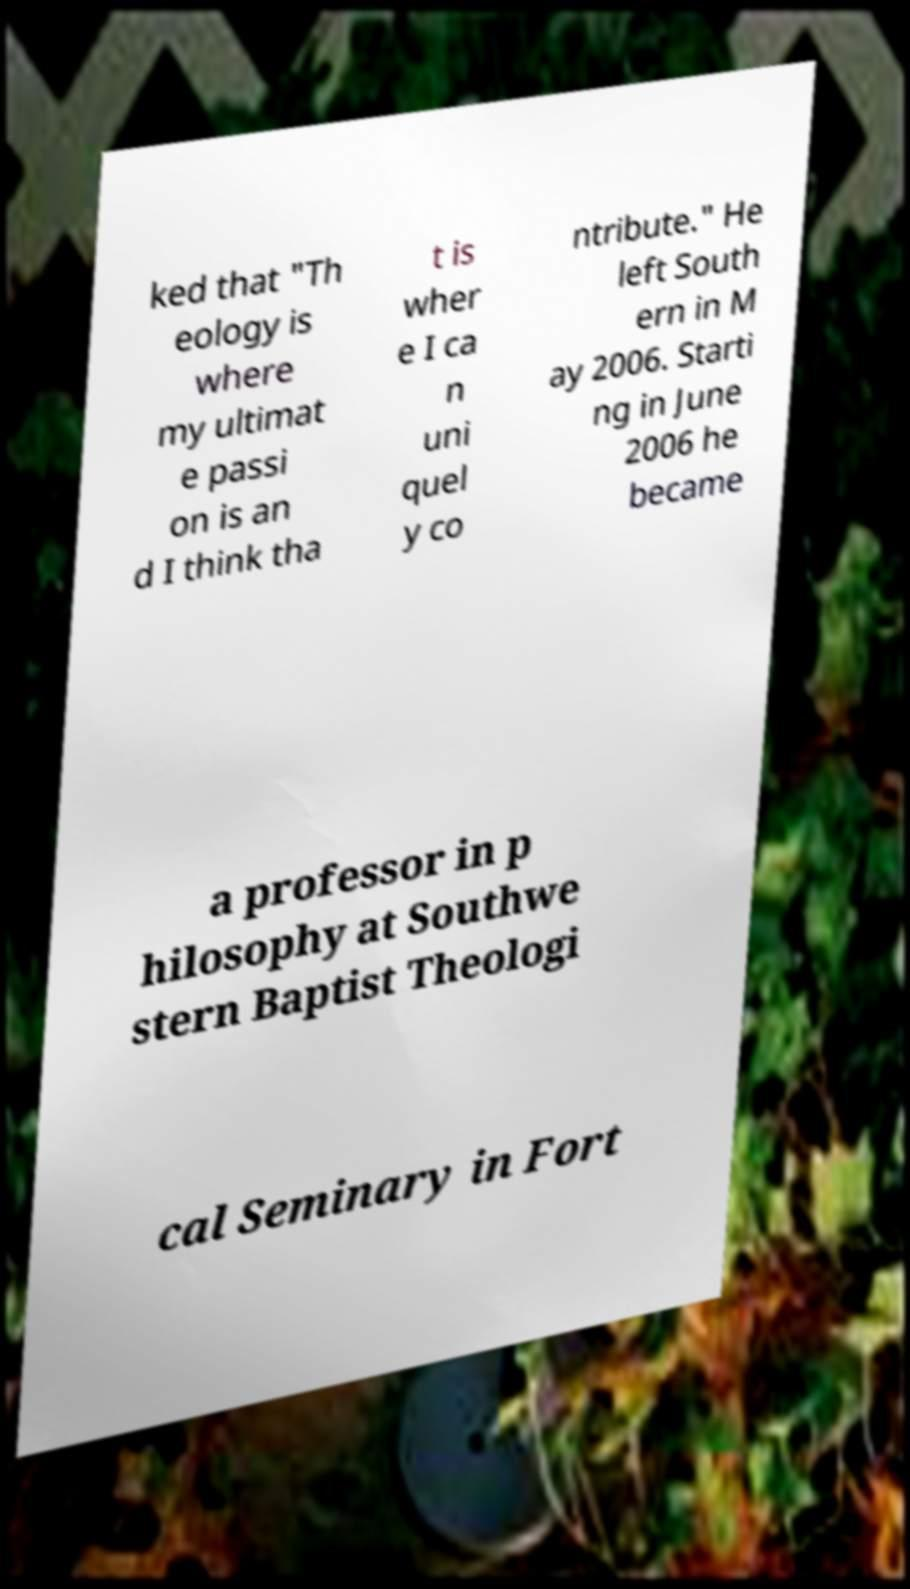Please read and relay the text visible in this image. What does it say? ked that "Th eology is where my ultimat e passi on is an d I think tha t is wher e I ca n uni quel y co ntribute." He left South ern in M ay 2006. Starti ng in June 2006 he became a professor in p hilosophy at Southwe stern Baptist Theologi cal Seminary in Fort 